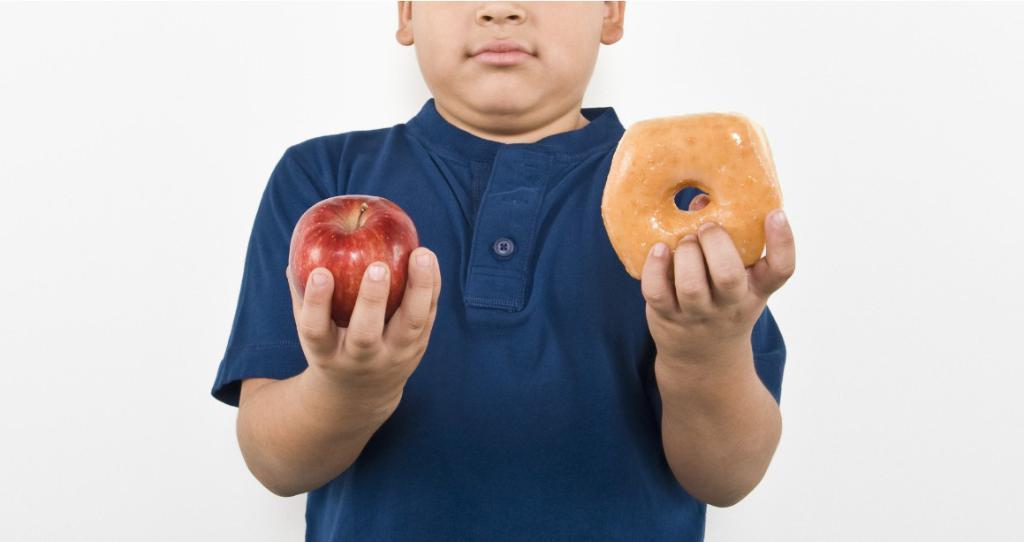What is the main subject of the image? The main subject of the image is a boy. What is the boy holding in the image? The boy is holding an apple and a doughnut. What can be seen in the background of the image? There is a wall visible in the image. Can you see any steam coming from the apple in the image? There is no steam visible in the image, as it features a boy holding an apple and a doughnut. 